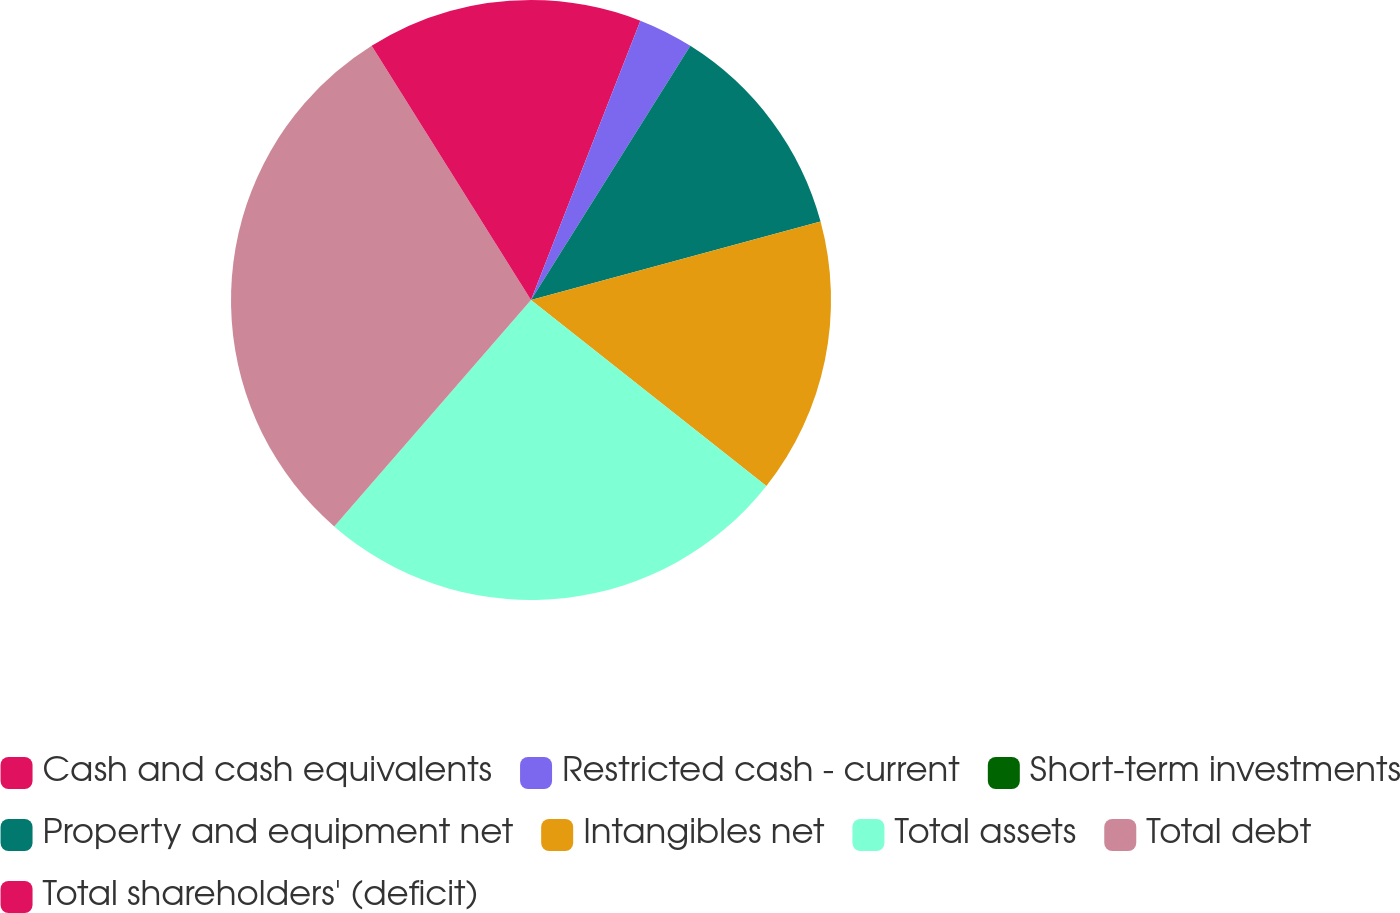Convert chart. <chart><loc_0><loc_0><loc_500><loc_500><pie_chart><fcel>Cash and cash equivalents<fcel>Restricted cash - current<fcel>Short-term investments<fcel>Property and equipment net<fcel>Intangibles net<fcel>Total assets<fcel>Total debt<fcel>Total shareholders' (deficit)<nl><fcel>5.94%<fcel>2.97%<fcel>0.0%<fcel>11.88%<fcel>14.85%<fcel>25.74%<fcel>29.7%<fcel>8.91%<nl></chart> 